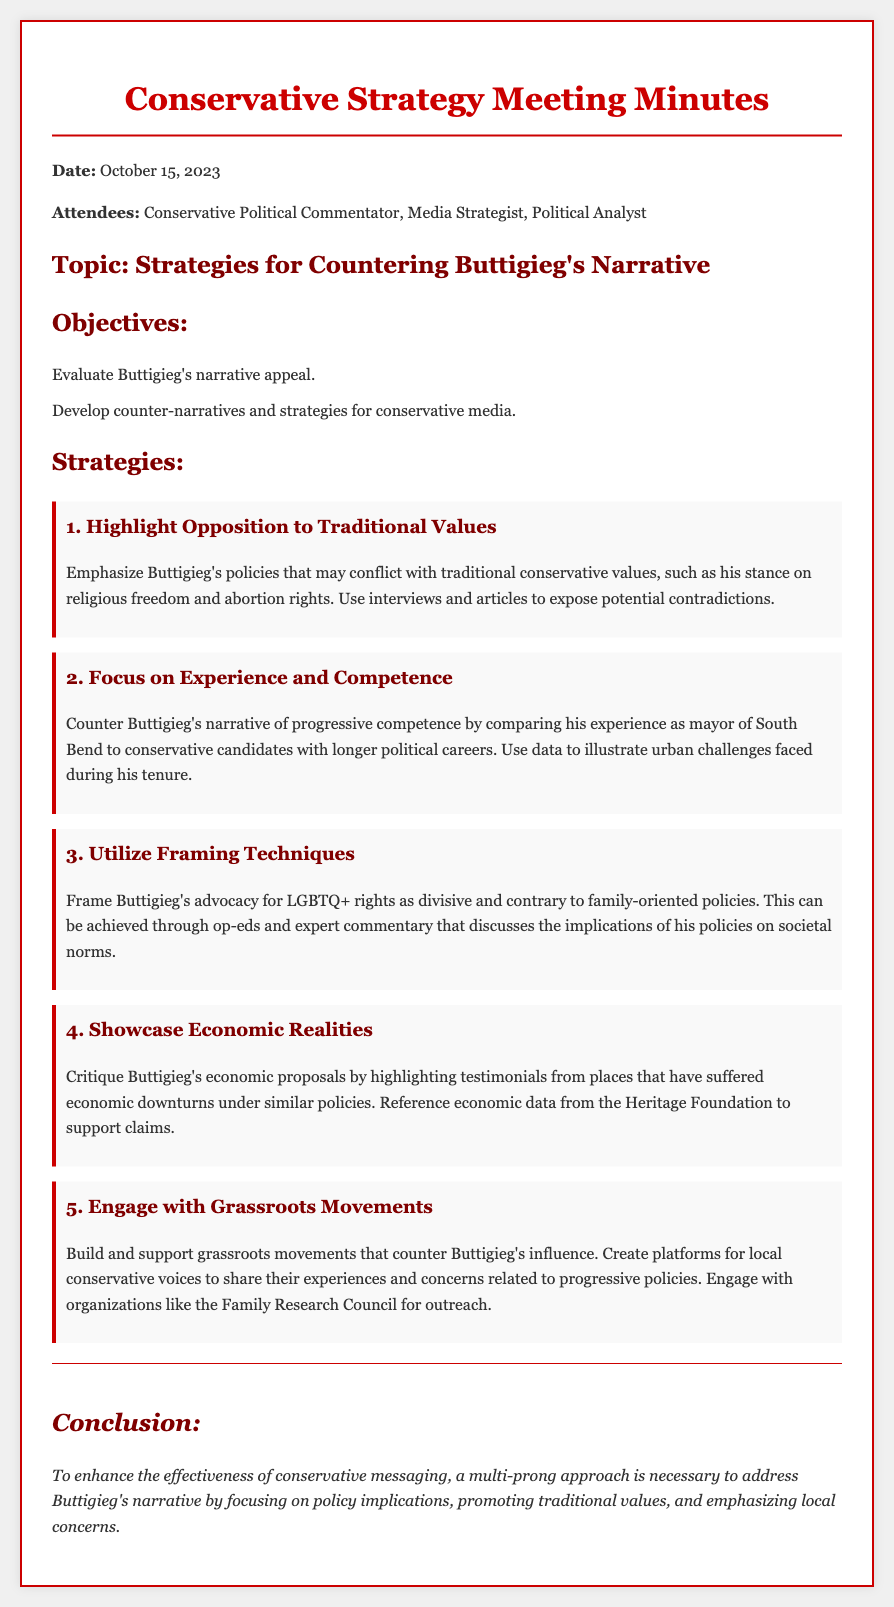What is the date of the meeting? The date is stated in the document as October 15, 2023.
Answer: October 15, 2023 Who attended the meeting? The attendees are listed in the document: Conservative Political Commentator, Media Strategist, Political Analyst.
Answer: Conservative Political Commentator, Media Strategist, Political Analyst What is one of the objectives of the meeting? The document lists the objectives, one of which is to develop counter-narratives and strategies for conservative media.
Answer: Develop counter-narratives and strategies for conservative media What is the first strategy discussed? The first strategy highlighted in the document is to emphasize Buttigieg's opposition to traditional values.
Answer: Highlight Opposition to Traditional Values Which organization is mentioned for grassroots engagement? The document references the Family Research Council as an organization for outreach and engagement.
Answer: Family Research Council What is a reasoning behind critiquing Buttigieg's economic proposals? The reasoning involves highlighting testimonials from places that have suffered economic downturns under similar policies.
Answer: Testimonials from places that have suffered economic downturns What is the concluding idea presented in the document? The conclusion emphasizes the necessity of a multi-prong approach to counter Buttigieg's narrative.
Answer: Multi-prong approach How many strategies are listed in the document? The document outlines a total of five strategies for countering Buttigieg's narrative.
Answer: Five strategies 